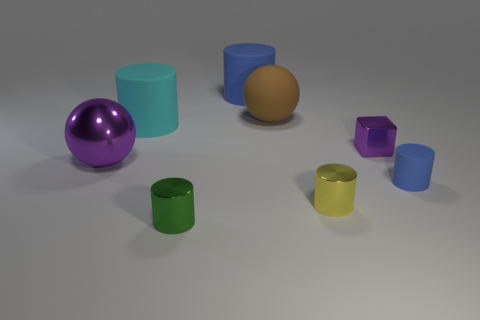Subtract all cyan cylinders. How many cylinders are left? 4 Subtract all yellow cylinders. How many cylinders are left? 4 Subtract all brown cylinders. Subtract all yellow balls. How many cylinders are left? 5 Add 1 big things. How many objects exist? 9 Subtract all balls. How many objects are left? 6 Add 7 tiny brown matte objects. How many tiny brown matte objects exist? 7 Subtract 0 yellow cubes. How many objects are left? 8 Subtract all cylinders. Subtract all yellow cubes. How many objects are left? 3 Add 4 tiny objects. How many tiny objects are left? 8 